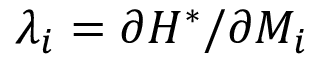Convert formula to latex. <formula><loc_0><loc_0><loc_500><loc_500>\lambda _ { i } = \partial H ^ { * } / \partial M _ { i }</formula> 